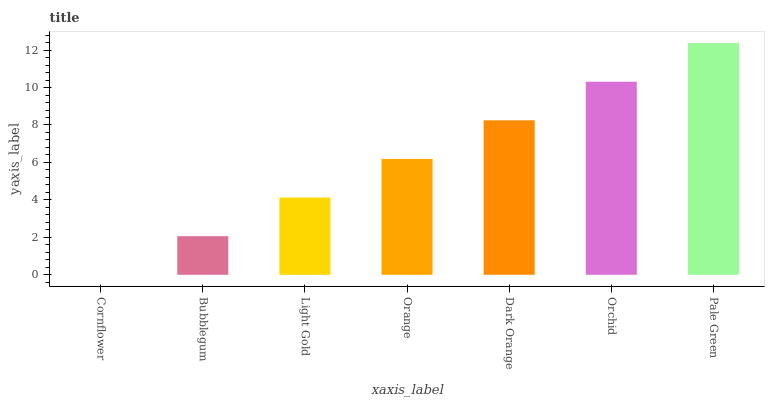Is Cornflower the minimum?
Answer yes or no. Yes. Is Pale Green the maximum?
Answer yes or no. Yes. Is Bubblegum the minimum?
Answer yes or no. No. Is Bubblegum the maximum?
Answer yes or no. No. Is Bubblegum greater than Cornflower?
Answer yes or no. Yes. Is Cornflower less than Bubblegum?
Answer yes or no. Yes. Is Cornflower greater than Bubblegum?
Answer yes or no. No. Is Bubblegum less than Cornflower?
Answer yes or no. No. Is Orange the high median?
Answer yes or no. Yes. Is Orange the low median?
Answer yes or no. Yes. Is Pale Green the high median?
Answer yes or no. No. Is Pale Green the low median?
Answer yes or no. No. 